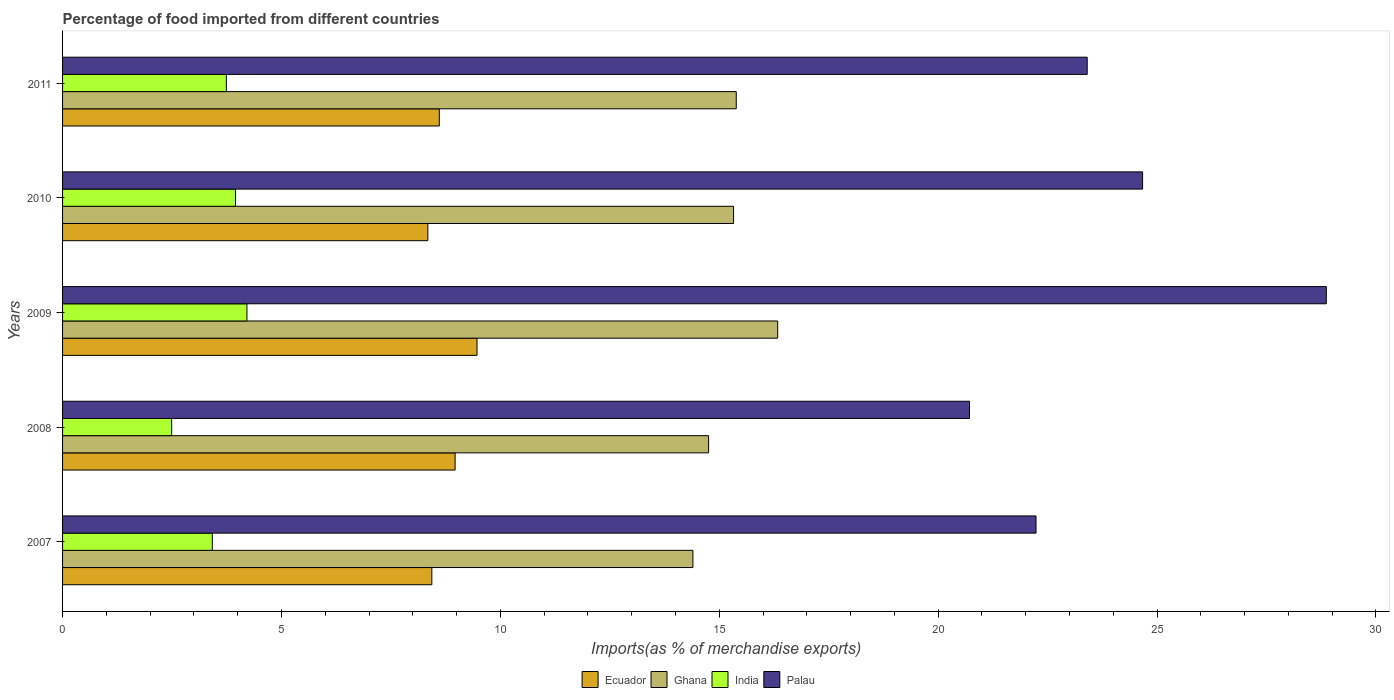How many different coloured bars are there?
Your response must be concise. 4. How many groups of bars are there?
Offer a terse response. 5. Are the number of bars per tick equal to the number of legend labels?
Give a very brief answer. Yes. Are the number of bars on each tick of the Y-axis equal?
Give a very brief answer. Yes. How many bars are there on the 2nd tick from the bottom?
Make the answer very short. 4. What is the label of the 2nd group of bars from the top?
Provide a succinct answer. 2010. What is the percentage of imports to different countries in Palau in 2009?
Keep it short and to the point. 28.87. Across all years, what is the maximum percentage of imports to different countries in Ghana?
Your answer should be compact. 16.33. Across all years, what is the minimum percentage of imports to different countries in Palau?
Your response must be concise. 20.72. In which year was the percentage of imports to different countries in Ecuador maximum?
Offer a terse response. 2009. In which year was the percentage of imports to different countries in Palau minimum?
Provide a succinct answer. 2008. What is the total percentage of imports to different countries in Ghana in the graph?
Keep it short and to the point. 76.2. What is the difference between the percentage of imports to different countries in Ghana in 2007 and that in 2009?
Offer a very short reply. -1.94. What is the difference between the percentage of imports to different countries in Ecuador in 2008 and the percentage of imports to different countries in Ghana in 2007?
Offer a terse response. -5.43. What is the average percentage of imports to different countries in Palau per year?
Provide a short and direct response. 23.98. In the year 2010, what is the difference between the percentage of imports to different countries in Palau and percentage of imports to different countries in Ecuador?
Make the answer very short. 16.33. In how many years, is the percentage of imports to different countries in Ecuador greater than 19 %?
Offer a very short reply. 0. What is the ratio of the percentage of imports to different countries in Ghana in 2008 to that in 2010?
Ensure brevity in your answer.  0.96. Is the difference between the percentage of imports to different countries in Palau in 2008 and 2009 greater than the difference between the percentage of imports to different countries in Ecuador in 2008 and 2009?
Keep it short and to the point. No. What is the difference between the highest and the second highest percentage of imports to different countries in Palau?
Provide a short and direct response. 4.2. What is the difference between the highest and the lowest percentage of imports to different countries in Ghana?
Make the answer very short. 1.94. In how many years, is the percentage of imports to different countries in Ghana greater than the average percentage of imports to different countries in Ghana taken over all years?
Keep it short and to the point. 3. Is the sum of the percentage of imports to different countries in India in 2008 and 2010 greater than the maximum percentage of imports to different countries in Ghana across all years?
Give a very brief answer. No. Is it the case that in every year, the sum of the percentage of imports to different countries in India and percentage of imports to different countries in Ghana is greater than the sum of percentage of imports to different countries in Palau and percentage of imports to different countries in Ecuador?
Offer a very short reply. No. What does the 1st bar from the bottom in 2008 represents?
Your response must be concise. Ecuador. How many bars are there?
Offer a terse response. 20. Are all the bars in the graph horizontal?
Ensure brevity in your answer.  Yes. How many years are there in the graph?
Keep it short and to the point. 5. Does the graph contain any zero values?
Keep it short and to the point. No. Does the graph contain grids?
Keep it short and to the point. No. What is the title of the graph?
Offer a very short reply. Percentage of food imported from different countries. Does "Tonga" appear as one of the legend labels in the graph?
Your answer should be compact. No. What is the label or title of the X-axis?
Make the answer very short. Imports(as % of merchandise exports). What is the label or title of the Y-axis?
Offer a terse response. Years. What is the Imports(as % of merchandise exports) in Ecuador in 2007?
Your response must be concise. 8.43. What is the Imports(as % of merchandise exports) in Ghana in 2007?
Your answer should be compact. 14.4. What is the Imports(as % of merchandise exports) of India in 2007?
Your response must be concise. 3.42. What is the Imports(as % of merchandise exports) of Palau in 2007?
Your answer should be very brief. 22.24. What is the Imports(as % of merchandise exports) of Ecuador in 2008?
Provide a succinct answer. 8.97. What is the Imports(as % of merchandise exports) in Ghana in 2008?
Your answer should be compact. 14.76. What is the Imports(as % of merchandise exports) in India in 2008?
Give a very brief answer. 2.49. What is the Imports(as % of merchandise exports) in Palau in 2008?
Your response must be concise. 20.72. What is the Imports(as % of merchandise exports) of Ecuador in 2009?
Give a very brief answer. 9.47. What is the Imports(as % of merchandise exports) in Ghana in 2009?
Your response must be concise. 16.33. What is the Imports(as % of merchandise exports) of India in 2009?
Your answer should be very brief. 4.21. What is the Imports(as % of merchandise exports) of Palau in 2009?
Provide a succinct answer. 28.87. What is the Imports(as % of merchandise exports) in Ecuador in 2010?
Your answer should be very brief. 8.34. What is the Imports(as % of merchandise exports) in Ghana in 2010?
Your answer should be very brief. 15.33. What is the Imports(as % of merchandise exports) in India in 2010?
Your answer should be very brief. 3.95. What is the Imports(as % of merchandise exports) in Palau in 2010?
Offer a very short reply. 24.67. What is the Imports(as % of merchandise exports) in Ecuador in 2011?
Ensure brevity in your answer.  8.61. What is the Imports(as % of merchandise exports) in Ghana in 2011?
Provide a succinct answer. 15.39. What is the Imports(as % of merchandise exports) in India in 2011?
Your answer should be very brief. 3.74. What is the Imports(as % of merchandise exports) of Palau in 2011?
Provide a short and direct response. 23.4. Across all years, what is the maximum Imports(as % of merchandise exports) in Ecuador?
Provide a succinct answer. 9.47. Across all years, what is the maximum Imports(as % of merchandise exports) in Ghana?
Ensure brevity in your answer.  16.33. Across all years, what is the maximum Imports(as % of merchandise exports) in India?
Ensure brevity in your answer.  4.21. Across all years, what is the maximum Imports(as % of merchandise exports) of Palau?
Provide a succinct answer. 28.87. Across all years, what is the minimum Imports(as % of merchandise exports) in Ecuador?
Provide a succinct answer. 8.34. Across all years, what is the minimum Imports(as % of merchandise exports) in Ghana?
Give a very brief answer. 14.4. Across all years, what is the minimum Imports(as % of merchandise exports) of India?
Provide a succinct answer. 2.49. Across all years, what is the minimum Imports(as % of merchandise exports) in Palau?
Give a very brief answer. 20.72. What is the total Imports(as % of merchandise exports) in Ecuador in the graph?
Offer a terse response. 43.82. What is the total Imports(as % of merchandise exports) of Ghana in the graph?
Your answer should be compact. 76.2. What is the total Imports(as % of merchandise exports) of India in the graph?
Offer a terse response. 17.82. What is the total Imports(as % of merchandise exports) in Palau in the graph?
Your answer should be very brief. 119.89. What is the difference between the Imports(as % of merchandise exports) in Ecuador in 2007 and that in 2008?
Your response must be concise. -0.53. What is the difference between the Imports(as % of merchandise exports) of Ghana in 2007 and that in 2008?
Your answer should be very brief. -0.36. What is the difference between the Imports(as % of merchandise exports) in India in 2007 and that in 2008?
Offer a terse response. 0.93. What is the difference between the Imports(as % of merchandise exports) in Palau in 2007 and that in 2008?
Provide a short and direct response. 1.52. What is the difference between the Imports(as % of merchandise exports) in Ecuador in 2007 and that in 2009?
Your answer should be very brief. -1.03. What is the difference between the Imports(as % of merchandise exports) of Ghana in 2007 and that in 2009?
Offer a very short reply. -1.94. What is the difference between the Imports(as % of merchandise exports) of India in 2007 and that in 2009?
Provide a succinct answer. -0.79. What is the difference between the Imports(as % of merchandise exports) in Palau in 2007 and that in 2009?
Ensure brevity in your answer.  -6.63. What is the difference between the Imports(as % of merchandise exports) in Ecuador in 2007 and that in 2010?
Provide a short and direct response. 0.09. What is the difference between the Imports(as % of merchandise exports) in Ghana in 2007 and that in 2010?
Give a very brief answer. -0.93. What is the difference between the Imports(as % of merchandise exports) in India in 2007 and that in 2010?
Ensure brevity in your answer.  -0.53. What is the difference between the Imports(as % of merchandise exports) in Palau in 2007 and that in 2010?
Offer a very short reply. -2.43. What is the difference between the Imports(as % of merchandise exports) in Ecuador in 2007 and that in 2011?
Offer a terse response. -0.17. What is the difference between the Imports(as % of merchandise exports) of Ghana in 2007 and that in 2011?
Offer a terse response. -0.99. What is the difference between the Imports(as % of merchandise exports) in India in 2007 and that in 2011?
Make the answer very short. -0.32. What is the difference between the Imports(as % of merchandise exports) of Palau in 2007 and that in 2011?
Offer a terse response. -1.17. What is the difference between the Imports(as % of merchandise exports) of Ecuador in 2008 and that in 2009?
Your answer should be compact. -0.5. What is the difference between the Imports(as % of merchandise exports) of Ghana in 2008 and that in 2009?
Provide a succinct answer. -1.58. What is the difference between the Imports(as % of merchandise exports) of India in 2008 and that in 2009?
Give a very brief answer. -1.72. What is the difference between the Imports(as % of merchandise exports) in Palau in 2008 and that in 2009?
Your answer should be very brief. -8.15. What is the difference between the Imports(as % of merchandise exports) of Ecuador in 2008 and that in 2010?
Give a very brief answer. 0.62. What is the difference between the Imports(as % of merchandise exports) of Ghana in 2008 and that in 2010?
Ensure brevity in your answer.  -0.57. What is the difference between the Imports(as % of merchandise exports) of India in 2008 and that in 2010?
Provide a succinct answer. -1.46. What is the difference between the Imports(as % of merchandise exports) in Palau in 2008 and that in 2010?
Your answer should be compact. -3.95. What is the difference between the Imports(as % of merchandise exports) of Ecuador in 2008 and that in 2011?
Give a very brief answer. 0.36. What is the difference between the Imports(as % of merchandise exports) in Ghana in 2008 and that in 2011?
Offer a terse response. -0.63. What is the difference between the Imports(as % of merchandise exports) in India in 2008 and that in 2011?
Keep it short and to the point. -1.25. What is the difference between the Imports(as % of merchandise exports) in Palau in 2008 and that in 2011?
Provide a succinct answer. -2.69. What is the difference between the Imports(as % of merchandise exports) in Ecuador in 2009 and that in 2010?
Keep it short and to the point. 1.12. What is the difference between the Imports(as % of merchandise exports) of Ghana in 2009 and that in 2010?
Give a very brief answer. 1.01. What is the difference between the Imports(as % of merchandise exports) of India in 2009 and that in 2010?
Offer a terse response. 0.26. What is the difference between the Imports(as % of merchandise exports) of Palau in 2009 and that in 2010?
Make the answer very short. 4.2. What is the difference between the Imports(as % of merchandise exports) in Ecuador in 2009 and that in 2011?
Provide a short and direct response. 0.86. What is the difference between the Imports(as % of merchandise exports) of Ghana in 2009 and that in 2011?
Offer a very short reply. 0.95. What is the difference between the Imports(as % of merchandise exports) of India in 2009 and that in 2011?
Offer a terse response. 0.47. What is the difference between the Imports(as % of merchandise exports) of Palau in 2009 and that in 2011?
Make the answer very short. 5.46. What is the difference between the Imports(as % of merchandise exports) of Ecuador in 2010 and that in 2011?
Your response must be concise. -0.26. What is the difference between the Imports(as % of merchandise exports) of Ghana in 2010 and that in 2011?
Offer a very short reply. -0.06. What is the difference between the Imports(as % of merchandise exports) in India in 2010 and that in 2011?
Make the answer very short. 0.21. What is the difference between the Imports(as % of merchandise exports) in Palau in 2010 and that in 2011?
Provide a succinct answer. 1.27. What is the difference between the Imports(as % of merchandise exports) of Ecuador in 2007 and the Imports(as % of merchandise exports) of Ghana in 2008?
Offer a very short reply. -6.32. What is the difference between the Imports(as % of merchandise exports) of Ecuador in 2007 and the Imports(as % of merchandise exports) of India in 2008?
Your answer should be compact. 5.94. What is the difference between the Imports(as % of merchandise exports) of Ecuador in 2007 and the Imports(as % of merchandise exports) of Palau in 2008?
Your answer should be very brief. -12.28. What is the difference between the Imports(as % of merchandise exports) of Ghana in 2007 and the Imports(as % of merchandise exports) of India in 2008?
Make the answer very short. 11.91. What is the difference between the Imports(as % of merchandise exports) of Ghana in 2007 and the Imports(as % of merchandise exports) of Palau in 2008?
Provide a succinct answer. -6.32. What is the difference between the Imports(as % of merchandise exports) of India in 2007 and the Imports(as % of merchandise exports) of Palau in 2008?
Ensure brevity in your answer.  -17.3. What is the difference between the Imports(as % of merchandise exports) in Ecuador in 2007 and the Imports(as % of merchandise exports) in Ghana in 2009?
Provide a succinct answer. -7.9. What is the difference between the Imports(as % of merchandise exports) of Ecuador in 2007 and the Imports(as % of merchandise exports) of India in 2009?
Your answer should be very brief. 4.22. What is the difference between the Imports(as % of merchandise exports) in Ecuador in 2007 and the Imports(as % of merchandise exports) in Palau in 2009?
Give a very brief answer. -20.43. What is the difference between the Imports(as % of merchandise exports) in Ghana in 2007 and the Imports(as % of merchandise exports) in India in 2009?
Your response must be concise. 10.19. What is the difference between the Imports(as % of merchandise exports) in Ghana in 2007 and the Imports(as % of merchandise exports) in Palau in 2009?
Keep it short and to the point. -14.47. What is the difference between the Imports(as % of merchandise exports) in India in 2007 and the Imports(as % of merchandise exports) in Palau in 2009?
Offer a terse response. -25.45. What is the difference between the Imports(as % of merchandise exports) of Ecuador in 2007 and the Imports(as % of merchandise exports) of Ghana in 2010?
Your answer should be very brief. -6.89. What is the difference between the Imports(as % of merchandise exports) of Ecuador in 2007 and the Imports(as % of merchandise exports) of India in 2010?
Provide a short and direct response. 4.48. What is the difference between the Imports(as % of merchandise exports) of Ecuador in 2007 and the Imports(as % of merchandise exports) of Palau in 2010?
Make the answer very short. -16.23. What is the difference between the Imports(as % of merchandise exports) of Ghana in 2007 and the Imports(as % of merchandise exports) of India in 2010?
Your answer should be very brief. 10.45. What is the difference between the Imports(as % of merchandise exports) of Ghana in 2007 and the Imports(as % of merchandise exports) of Palau in 2010?
Keep it short and to the point. -10.27. What is the difference between the Imports(as % of merchandise exports) of India in 2007 and the Imports(as % of merchandise exports) of Palau in 2010?
Offer a very short reply. -21.25. What is the difference between the Imports(as % of merchandise exports) in Ecuador in 2007 and the Imports(as % of merchandise exports) in Ghana in 2011?
Make the answer very short. -6.95. What is the difference between the Imports(as % of merchandise exports) of Ecuador in 2007 and the Imports(as % of merchandise exports) of India in 2011?
Make the answer very short. 4.69. What is the difference between the Imports(as % of merchandise exports) in Ecuador in 2007 and the Imports(as % of merchandise exports) in Palau in 2011?
Ensure brevity in your answer.  -14.97. What is the difference between the Imports(as % of merchandise exports) in Ghana in 2007 and the Imports(as % of merchandise exports) in India in 2011?
Your answer should be very brief. 10.66. What is the difference between the Imports(as % of merchandise exports) of Ghana in 2007 and the Imports(as % of merchandise exports) of Palau in 2011?
Make the answer very short. -9.01. What is the difference between the Imports(as % of merchandise exports) of India in 2007 and the Imports(as % of merchandise exports) of Palau in 2011?
Offer a very short reply. -19.98. What is the difference between the Imports(as % of merchandise exports) of Ecuador in 2008 and the Imports(as % of merchandise exports) of Ghana in 2009?
Provide a succinct answer. -7.37. What is the difference between the Imports(as % of merchandise exports) of Ecuador in 2008 and the Imports(as % of merchandise exports) of India in 2009?
Give a very brief answer. 4.75. What is the difference between the Imports(as % of merchandise exports) in Ecuador in 2008 and the Imports(as % of merchandise exports) in Palau in 2009?
Give a very brief answer. -19.9. What is the difference between the Imports(as % of merchandise exports) in Ghana in 2008 and the Imports(as % of merchandise exports) in India in 2009?
Your response must be concise. 10.54. What is the difference between the Imports(as % of merchandise exports) of Ghana in 2008 and the Imports(as % of merchandise exports) of Palau in 2009?
Your answer should be very brief. -14.11. What is the difference between the Imports(as % of merchandise exports) of India in 2008 and the Imports(as % of merchandise exports) of Palau in 2009?
Provide a succinct answer. -26.37. What is the difference between the Imports(as % of merchandise exports) of Ecuador in 2008 and the Imports(as % of merchandise exports) of Ghana in 2010?
Your answer should be compact. -6.36. What is the difference between the Imports(as % of merchandise exports) in Ecuador in 2008 and the Imports(as % of merchandise exports) in India in 2010?
Ensure brevity in your answer.  5.02. What is the difference between the Imports(as % of merchandise exports) of Ecuador in 2008 and the Imports(as % of merchandise exports) of Palau in 2010?
Keep it short and to the point. -15.7. What is the difference between the Imports(as % of merchandise exports) of Ghana in 2008 and the Imports(as % of merchandise exports) of India in 2010?
Keep it short and to the point. 10.81. What is the difference between the Imports(as % of merchandise exports) of Ghana in 2008 and the Imports(as % of merchandise exports) of Palau in 2010?
Your answer should be compact. -9.91. What is the difference between the Imports(as % of merchandise exports) of India in 2008 and the Imports(as % of merchandise exports) of Palau in 2010?
Provide a succinct answer. -22.18. What is the difference between the Imports(as % of merchandise exports) of Ecuador in 2008 and the Imports(as % of merchandise exports) of Ghana in 2011?
Keep it short and to the point. -6.42. What is the difference between the Imports(as % of merchandise exports) in Ecuador in 2008 and the Imports(as % of merchandise exports) in India in 2011?
Offer a very short reply. 5.23. What is the difference between the Imports(as % of merchandise exports) of Ecuador in 2008 and the Imports(as % of merchandise exports) of Palau in 2011?
Your response must be concise. -14.44. What is the difference between the Imports(as % of merchandise exports) in Ghana in 2008 and the Imports(as % of merchandise exports) in India in 2011?
Your answer should be compact. 11.02. What is the difference between the Imports(as % of merchandise exports) in Ghana in 2008 and the Imports(as % of merchandise exports) in Palau in 2011?
Give a very brief answer. -8.65. What is the difference between the Imports(as % of merchandise exports) of India in 2008 and the Imports(as % of merchandise exports) of Palau in 2011?
Provide a succinct answer. -20.91. What is the difference between the Imports(as % of merchandise exports) in Ecuador in 2009 and the Imports(as % of merchandise exports) in Ghana in 2010?
Your answer should be very brief. -5.86. What is the difference between the Imports(as % of merchandise exports) of Ecuador in 2009 and the Imports(as % of merchandise exports) of India in 2010?
Your response must be concise. 5.52. What is the difference between the Imports(as % of merchandise exports) in Ecuador in 2009 and the Imports(as % of merchandise exports) in Palau in 2010?
Your response must be concise. -15.2. What is the difference between the Imports(as % of merchandise exports) in Ghana in 2009 and the Imports(as % of merchandise exports) in India in 2010?
Give a very brief answer. 12.38. What is the difference between the Imports(as % of merchandise exports) in Ghana in 2009 and the Imports(as % of merchandise exports) in Palau in 2010?
Your response must be concise. -8.34. What is the difference between the Imports(as % of merchandise exports) in India in 2009 and the Imports(as % of merchandise exports) in Palau in 2010?
Your answer should be very brief. -20.46. What is the difference between the Imports(as % of merchandise exports) of Ecuador in 2009 and the Imports(as % of merchandise exports) of Ghana in 2011?
Offer a very short reply. -5.92. What is the difference between the Imports(as % of merchandise exports) of Ecuador in 2009 and the Imports(as % of merchandise exports) of India in 2011?
Your response must be concise. 5.73. What is the difference between the Imports(as % of merchandise exports) of Ecuador in 2009 and the Imports(as % of merchandise exports) of Palau in 2011?
Your response must be concise. -13.94. What is the difference between the Imports(as % of merchandise exports) of Ghana in 2009 and the Imports(as % of merchandise exports) of India in 2011?
Provide a succinct answer. 12.59. What is the difference between the Imports(as % of merchandise exports) of Ghana in 2009 and the Imports(as % of merchandise exports) of Palau in 2011?
Make the answer very short. -7.07. What is the difference between the Imports(as % of merchandise exports) in India in 2009 and the Imports(as % of merchandise exports) in Palau in 2011?
Offer a very short reply. -19.19. What is the difference between the Imports(as % of merchandise exports) in Ecuador in 2010 and the Imports(as % of merchandise exports) in Ghana in 2011?
Keep it short and to the point. -7.04. What is the difference between the Imports(as % of merchandise exports) in Ecuador in 2010 and the Imports(as % of merchandise exports) in India in 2011?
Your answer should be very brief. 4.6. What is the difference between the Imports(as % of merchandise exports) in Ecuador in 2010 and the Imports(as % of merchandise exports) in Palau in 2011?
Provide a short and direct response. -15.06. What is the difference between the Imports(as % of merchandise exports) in Ghana in 2010 and the Imports(as % of merchandise exports) in India in 2011?
Your answer should be compact. 11.59. What is the difference between the Imports(as % of merchandise exports) in Ghana in 2010 and the Imports(as % of merchandise exports) in Palau in 2011?
Your response must be concise. -8.08. What is the difference between the Imports(as % of merchandise exports) of India in 2010 and the Imports(as % of merchandise exports) of Palau in 2011?
Your answer should be compact. -19.45. What is the average Imports(as % of merchandise exports) in Ecuador per year?
Your answer should be compact. 8.76. What is the average Imports(as % of merchandise exports) of Ghana per year?
Make the answer very short. 15.24. What is the average Imports(as % of merchandise exports) of India per year?
Offer a very short reply. 3.56. What is the average Imports(as % of merchandise exports) in Palau per year?
Give a very brief answer. 23.98. In the year 2007, what is the difference between the Imports(as % of merchandise exports) in Ecuador and Imports(as % of merchandise exports) in Ghana?
Offer a terse response. -5.96. In the year 2007, what is the difference between the Imports(as % of merchandise exports) in Ecuador and Imports(as % of merchandise exports) in India?
Give a very brief answer. 5.01. In the year 2007, what is the difference between the Imports(as % of merchandise exports) of Ecuador and Imports(as % of merchandise exports) of Palau?
Keep it short and to the point. -13.8. In the year 2007, what is the difference between the Imports(as % of merchandise exports) of Ghana and Imports(as % of merchandise exports) of India?
Keep it short and to the point. 10.98. In the year 2007, what is the difference between the Imports(as % of merchandise exports) of Ghana and Imports(as % of merchandise exports) of Palau?
Ensure brevity in your answer.  -7.84. In the year 2007, what is the difference between the Imports(as % of merchandise exports) in India and Imports(as % of merchandise exports) in Palau?
Offer a terse response. -18.81. In the year 2008, what is the difference between the Imports(as % of merchandise exports) in Ecuador and Imports(as % of merchandise exports) in Ghana?
Keep it short and to the point. -5.79. In the year 2008, what is the difference between the Imports(as % of merchandise exports) of Ecuador and Imports(as % of merchandise exports) of India?
Offer a very short reply. 6.47. In the year 2008, what is the difference between the Imports(as % of merchandise exports) of Ecuador and Imports(as % of merchandise exports) of Palau?
Your response must be concise. -11.75. In the year 2008, what is the difference between the Imports(as % of merchandise exports) in Ghana and Imports(as % of merchandise exports) in India?
Your answer should be compact. 12.26. In the year 2008, what is the difference between the Imports(as % of merchandise exports) of Ghana and Imports(as % of merchandise exports) of Palau?
Provide a succinct answer. -5.96. In the year 2008, what is the difference between the Imports(as % of merchandise exports) in India and Imports(as % of merchandise exports) in Palau?
Your answer should be very brief. -18.22. In the year 2009, what is the difference between the Imports(as % of merchandise exports) of Ecuador and Imports(as % of merchandise exports) of Ghana?
Provide a succinct answer. -6.87. In the year 2009, what is the difference between the Imports(as % of merchandise exports) of Ecuador and Imports(as % of merchandise exports) of India?
Your answer should be compact. 5.25. In the year 2009, what is the difference between the Imports(as % of merchandise exports) of Ecuador and Imports(as % of merchandise exports) of Palau?
Your response must be concise. -19.4. In the year 2009, what is the difference between the Imports(as % of merchandise exports) in Ghana and Imports(as % of merchandise exports) in India?
Your answer should be compact. 12.12. In the year 2009, what is the difference between the Imports(as % of merchandise exports) of Ghana and Imports(as % of merchandise exports) of Palau?
Ensure brevity in your answer.  -12.53. In the year 2009, what is the difference between the Imports(as % of merchandise exports) of India and Imports(as % of merchandise exports) of Palau?
Make the answer very short. -24.65. In the year 2010, what is the difference between the Imports(as % of merchandise exports) in Ecuador and Imports(as % of merchandise exports) in Ghana?
Your answer should be compact. -6.98. In the year 2010, what is the difference between the Imports(as % of merchandise exports) of Ecuador and Imports(as % of merchandise exports) of India?
Offer a very short reply. 4.39. In the year 2010, what is the difference between the Imports(as % of merchandise exports) in Ecuador and Imports(as % of merchandise exports) in Palau?
Give a very brief answer. -16.33. In the year 2010, what is the difference between the Imports(as % of merchandise exports) in Ghana and Imports(as % of merchandise exports) in India?
Offer a very short reply. 11.38. In the year 2010, what is the difference between the Imports(as % of merchandise exports) of Ghana and Imports(as % of merchandise exports) of Palau?
Provide a succinct answer. -9.34. In the year 2010, what is the difference between the Imports(as % of merchandise exports) in India and Imports(as % of merchandise exports) in Palau?
Your response must be concise. -20.72. In the year 2011, what is the difference between the Imports(as % of merchandise exports) in Ecuador and Imports(as % of merchandise exports) in Ghana?
Ensure brevity in your answer.  -6.78. In the year 2011, what is the difference between the Imports(as % of merchandise exports) of Ecuador and Imports(as % of merchandise exports) of India?
Your response must be concise. 4.86. In the year 2011, what is the difference between the Imports(as % of merchandise exports) in Ecuador and Imports(as % of merchandise exports) in Palau?
Your response must be concise. -14.8. In the year 2011, what is the difference between the Imports(as % of merchandise exports) of Ghana and Imports(as % of merchandise exports) of India?
Provide a succinct answer. 11.65. In the year 2011, what is the difference between the Imports(as % of merchandise exports) in Ghana and Imports(as % of merchandise exports) in Palau?
Offer a terse response. -8.02. In the year 2011, what is the difference between the Imports(as % of merchandise exports) of India and Imports(as % of merchandise exports) of Palau?
Give a very brief answer. -19.66. What is the ratio of the Imports(as % of merchandise exports) in Ecuador in 2007 to that in 2008?
Offer a very short reply. 0.94. What is the ratio of the Imports(as % of merchandise exports) in Ghana in 2007 to that in 2008?
Make the answer very short. 0.98. What is the ratio of the Imports(as % of merchandise exports) of India in 2007 to that in 2008?
Ensure brevity in your answer.  1.37. What is the ratio of the Imports(as % of merchandise exports) in Palau in 2007 to that in 2008?
Provide a succinct answer. 1.07. What is the ratio of the Imports(as % of merchandise exports) in Ecuador in 2007 to that in 2009?
Provide a succinct answer. 0.89. What is the ratio of the Imports(as % of merchandise exports) in Ghana in 2007 to that in 2009?
Ensure brevity in your answer.  0.88. What is the ratio of the Imports(as % of merchandise exports) in India in 2007 to that in 2009?
Your answer should be very brief. 0.81. What is the ratio of the Imports(as % of merchandise exports) in Palau in 2007 to that in 2009?
Provide a short and direct response. 0.77. What is the ratio of the Imports(as % of merchandise exports) in Ecuador in 2007 to that in 2010?
Provide a short and direct response. 1.01. What is the ratio of the Imports(as % of merchandise exports) in Ghana in 2007 to that in 2010?
Offer a very short reply. 0.94. What is the ratio of the Imports(as % of merchandise exports) in India in 2007 to that in 2010?
Keep it short and to the point. 0.87. What is the ratio of the Imports(as % of merchandise exports) of Palau in 2007 to that in 2010?
Offer a terse response. 0.9. What is the ratio of the Imports(as % of merchandise exports) of Ecuador in 2007 to that in 2011?
Your answer should be very brief. 0.98. What is the ratio of the Imports(as % of merchandise exports) in Ghana in 2007 to that in 2011?
Your answer should be very brief. 0.94. What is the ratio of the Imports(as % of merchandise exports) of India in 2007 to that in 2011?
Ensure brevity in your answer.  0.91. What is the ratio of the Imports(as % of merchandise exports) of Palau in 2007 to that in 2011?
Your answer should be very brief. 0.95. What is the ratio of the Imports(as % of merchandise exports) of Ecuador in 2008 to that in 2009?
Provide a succinct answer. 0.95. What is the ratio of the Imports(as % of merchandise exports) of Ghana in 2008 to that in 2009?
Your response must be concise. 0.9. What is the ratio of the Imports(as % of merchandise exports) of India in 2008 to that in 2009?
Your response must be concise. 0.59. What is the ratio of the Imports(as % of merchandise exports) of Palau in 2008 to that in 2009?
Give a very brief answer. 0.72. What is the ratio of the Imports(as % of merchandise exports) in Ecuador in 2008 to that in 2010?
Offer a very short reply. 1.07. What is the ratio of the Imports(as % of merchandise exports) in Ghana in 2008 to that in 2010?
Keep it short and to the point. 0.96. What is the ratio of the Imports(as % of merchandise exports) in India in 2008 to that in 2010?
Make the answer very short. 0.63. What is the ratio of the Imports(as % of merchandise exports) of Palau in 2008 to that in 2010?
Ensure brevity in your answer.  0.84. What is the ratio of the Imports(as % of merchandise exports) in Ecuador in 2008 to that in 2011?
Offer a terse response. 1.04. What is the ratio of the Imports(as % of merchandise exports) of Ghana in 2008 to that in 2011?
Make the answer very short. 0.96. What is the ratio of the Imports(as % of merchandise exports) in India in 2008 to that in 2011?
Ensure brevity in your answer.  0.67. What is the ratio of the Imports(as % of merchandise exports) of Palau in 2008 to that in 2011?
Ensure brevity in your answer.  0.89. What is the ratio of the Imports(as % of merchandise exports) of Ecuador in 2009 to that in 2010?
Ensure brevity in your answer.  1.13. What is the ratio of the Imports(as % of merchandise exports) of Ghana in 2009 to that in 2010?
Ensure brevity in your answer.  1.07. What is the ratio of the Imports(as % of merchandise exports) of India in 2009 to that in 2010?
Keep it short and to the point. 1.07. What is the ratio of the Imports(as % of merchandise exports) of Palau in 2009 to that in 2010?
Keep it short and to the point. 1.17. What is the ratio of the Imports(as % of merchandise exports) of Ecuador in 2009 to that in 2011?
Keep it short and to the point. 1.1. What is the ratio of the Imports(as % of merchandise exports) of Ghana in 2009 to that in 2011?
Your answer should be compact. 1.06. What is the ratio of the Imports(as % of merchandise exports) of India in 2009 to that in 2011?
Your answer should be compact. 1.13. What is the ratio of the Imports(as % of merchandise exports) in Palau in 2009 to that in 2011?
Make the answer very short. 1.23. What is the ratio of the Imports(as % of merchandise exports) in Ecuador in 2010 to that in 2011?
Provide a succinct answer. 0.97. What is the ratio of the Imports(as % of merchandise exports) of Ghana in 2010 to that in 2011?
Offer a terse response. 1. What is the ratio of the Imports(as % of merchandise exports) of India in 2010 to that in 2011?
Ensure brevity in your answer.  1.06. What is the ratio of the Imports(as % of merchandise exports) in Palau in 2010 to that in 2011?
Give a very brief answer. 1.05. What is the difference between the highest and the second highest Imports(as % of merchandise exports) of Ecuador?
Make the answer very short. 0.5. What is the difference between the highest and the second highest Imports(as % of merchandise exports) in Ghana?
Ensure brevity in your answer.  0.95. What is the difference between the highest and the second highest Imports(as % of merchandise exports) in India?
Offer a terse response. 0.26. What is the difference between the highest and the second highest Imports(as % of merchandise exports) of Palau?
Your answer should be very brief. 4.2. What is the difference between the highest and the lowest Imports(as % of merchandise exports) in Ecuador?
Your answer should be very brief. 1.12. What is the difference between the highest and the lowest Imports(as % of merchandise exports) in Ghana?
Your answer should be very brief. 1.94. What is the difference between the highest and the lowest Imports(as % of merchandise exports) of India?
Provide a short and direct response. 1.72. What is the difference between the highest and the lowest Imports(as % of merchandise exports) in Palau?
Provide a short and direct response. 8.15. 